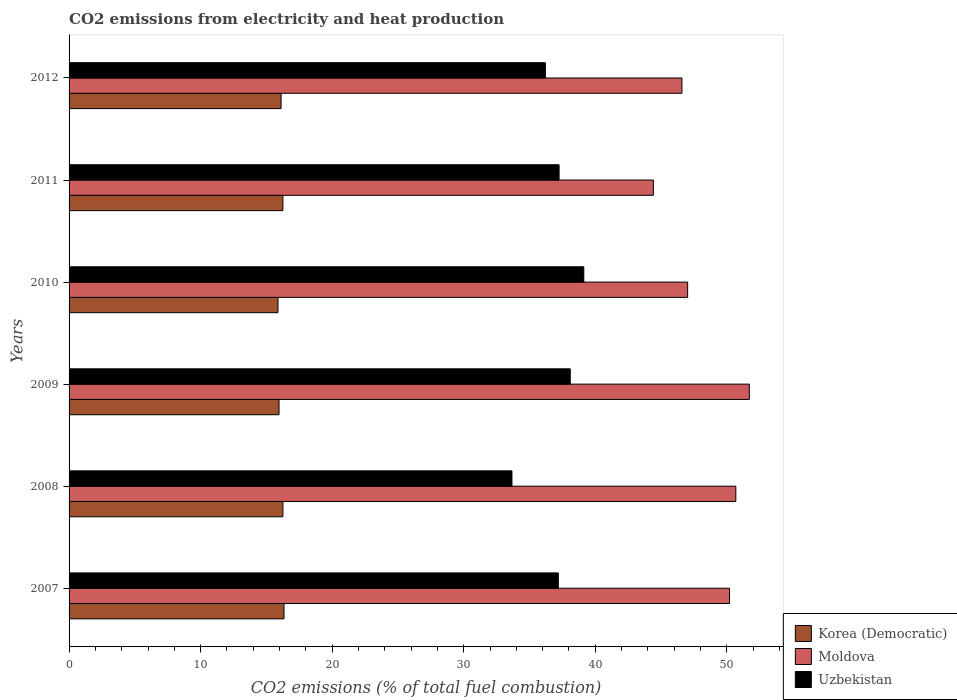How many different coloured bars are there?
Your answer should be very brief. 3. How many groups of bars are there?
Offer a terse response. 6. What is the label of the 4th group of bars from the top?
Give a very brief answer. 2009. What is the amount of CO2 emitted in Uzbekistan in 2007?
Ensure brevity in your answer.  37.19. Across all years, what is the maximum amount of CO2 emitted in Moldova?
Your response must be concise. 51.71. Across all years, what is the minimum amount of CO2 emitted in Korea (Democratic)?
Give a very brief answer. 15.88. In which year was the amount of CO2 emitted in Moldova maximum?
Offer a terse response. 2009. What is the total amount of CO2 emitted in Moldova in the graph?
Offer a terse response. 290.62. What is the difference between the amount of CO2 emitted in Korea (Democratic) in 2009 and that in 2011?
Your answer should be very brief. -0.29. What is the difference between the amount of CO2 emitted in Korea (Democratic) in 2011 and the amount of CO2 emitted in Uzbekistan in 2007?
Ensure brevity in your answer.  -20.94. What is the average amount of CO2 emitted in Moldova per year?
Your answer should be very brief. 48.44. In the year 2011, what is the difference between the amount of CO2 emitted in Uzbekistan and amount of CO2 emitted in Moldova?
Offer a very short reply. -7.17. In how many years, is the amount of CO2 emitted in Korea (Democratic) greater than 16 %?
Ensure brevity in your answer.  4. What is the ratio of the amount of CO2 emitted in Korea (Democratic) in 2010 to that in 2012?
Offer a terse response. 0.99. Is the difference between the amount of CO2 emitted in Uzbekistan in 2007 and 2011 greater than the difference between the amount of CO2 emitted in Moldova in 2007 and 2011?
Keep it short and to the point. No. What is the difference between the highest and the second highest amount of CO2 emitted in Moldova?
Your answer should be very brief. 1.03. What is the difference between the highest and the lowest amount of CO2 emitted in Uzbekistan?
Keep it short and to the point. 5.46. In how many years, is the amount of CO2 emitted in Korea (Democratic) greater than the average amount of CO2 emitted in Korea (Democratic) taken over all years?
Give a very brief answer. 3. Is the sum of the amount of CO2 emitted in Uzbekistan in 2008 and 2009 greater than the maximum amount of CO2 emitted in Korea (Democratic) across all years?
Your response must be concise. Yes. What does the 1st bar from the top in 2010 represents?
Make the answer very short. Uzbekistan. What does the 2nd bar from the bottom in 2010 represents?
Offer a very short reply. Moldova. How many bars are there?
Your answer should be very brief. 18. Are all the bars in the graph horizontal?
Ensure brevity in your answer.  Yes. How many years are there in the graph?
Offer a terse response. 6. What is the difference between two consecutive major ticks on the X-axis?
Your answer should be compact. 10. Does the graph contain any zero values?
Provide a succinct answer. No. Where does the legend appear in the graph?
Ensure brevity in your answer.  Bottom right. How many legend labels are there?
Make the answer very short. 3. What is the title of the graph?
Make the answer very short. CO2 emissions from electricity and heat production. What is the label or title of the X-axis?
Offer a very short reply. CO2 emissions (% of total fuel combustion). What is the label or title of the Y-axis?
Make the answer very short. Years. What is the CO2 emissions (% of total fuel combustion) of Korea (Democratic) in 2007?
Keep it short and to the point. 16.34. What is the CO2 emissions (% of total fuel combustion) of Moldova in 2007?
Your response must be concise. 50.2. What is the CO2 emissions (% of total fuel combustion) in Uzbekistan in 2007?
Your response must be concise. 37.19. What is the CO2 emissions (% of total fuel combustion) of Korea (Democratic) in 2008?
Offer a very short reply. 16.26. What is the CO2 emissions (% of total fuel combustion) of Moldova in 2008?
Ensure brevity in your answer.  50.68. What is the CO2 emissions (% of total fuel combustion) in Uzbekistan in 2008?
Give a very brief answer. 33.67. What is the CO2 emissions (% of total fuel combustion) of Korea (Democratic) in 2009?
Offer a terse response. 15.96. What is the CO2 emissions (% of total fuel combustion) of Moldova in 2009?
Give a very brief answer. 51.71. What is the CO2 emissions (% of total fuel combustion) of Uzbekistan in 2009?
Make the answer very short. 38.1. What is the CO2 emissions (% of total fuel combustion) in Korea (Democratic) in 2010?
Your answer should be very brief. 15.88. What is the CO2 emissions (% of total fuel combustion) of Moldova in 2010?
Give a very brief answer. 47.02. What is the CO2 emissions (% of total fuel combustion) of Uzbekistan in 2010?
Keep it short and to the point. 39.13. What is the CO2 emissions (% of total fuel combustion) in Korea (Democratic) in 2011?
Offer a terse response. 16.25. What is the CO2 emissions (% of total fuel combustion) of Moldova in 2011?
Provide a succinct answer. 44.42. What is the CO2 emissions (% of total fuel combustion) of Uzbekistan in 2011?
Your answer should be compact. 37.25. What is the CO2 emissions (% of total fuel combustion) of Korea (Democratic) in 2012?
Give a very brief answer. 16.12. What is the CO2 emissions (% of total fuel combustion) of Moldova in 2012?
Provide a succinct answer. 46.59. What is the CO2 emissions (% of total fuel combustion) of Uzbekistan in 2012?
Ensure brevity in your answer.  36.21. Across all years, what is the maximum CO2 emissions (% of total fuel combustion) of Korea (Democratic)?
Provide a short and direct response. 16.34. Across all years, what is the maximum CO2 emissions (% of total fuel combustion) of Moldova?
Your answer should be very brief. 51.71. Across all years, what is the maximum CO2 emissions (% of total fuel combustion) in Uzbekistan?
Provide a succinct answer. 39.13. Across all years, what is the minimum CO2 emissions (% of total fuel combustion) of Korea (Democratic)?
Your answer should be very brief. 15.88. Across all years, what is the minimum CO2 emissions (% of total fuel combustion) in Moldova?
Give a very brief answer. 44.42. Across all years, what is the minimum CO2 emissions (% of total fuel combustion) in Uzbekistan?
Offer a terse response. 33.67. What is the total CO2 emissions (% of total fuel combustion) of Korea (Democratic) in the graph?
Provide a short and direct response. 96.81. What is the total CO2 emissions (% of total fuel combustion) in Moldova in the graph?
Your answer should be very brief. 290.62. What is the total CO2 emissions (% of total fuel combustion) in Uzbekistan in the graph?
Offer a very short reply. 221.54. What is the difference between the CO2 emissions (% of total fuel combustion) of Korea (Democratic) in 2007 and that in 2008?
Provide a short and direct response. 0.08. What is the difference between the CO2 emissions (% of total fuel combustion) of Moldova in 2007 and that in 2008?
Your answer should be compact. -0.48. What is the difference between the CO2 emissions (% of total fuel combustion) in Uzbekistan in 2007 and that in 2008?
Provide a succinct answer. 3.53. What is the difference between the CO2 emissions (% of total fuel combustion) in Korea (Democratic) in 2007 and that in 2009?
Provide a succinct answer. 0.38. What is the difference between the CO2 emissions (% of total fuel combustion) in Moldova in 2007 and that in 2009?
Your answer should be very brief. -1.51. What is the difference between the CO2 emissions (% of total fuel combustion) of Uzbekistan in 2007 and that in 2009?
Provide a succinct answer. -0.91. What is the difference between the CO2 emissions (% of total fuel combustion) of Korea (Democratic) in 2007 and that in 2010?
Ensure brevity in your answer.  0.46. What is the difference between the CO2 emissions (% of total fuel combustion) in Moldova in 2007 and that in 2010?
Offer a very short reply. 3.18. What is the difference between the CO2 emissions (% of total fuel combustion) of Uzbekistan in 2007 and that in 2010?
Give a very brief answer. -1.94. What is the difference between the CO2 emissions (% of total fuel combustion) in Korea (Democratic) in 2007 and that in 2011?
Provide a short and direct response. 0.09. What is the difference between the CO2 emissions (% of total fuel combustion) in Moldova in 2007 and that in 2011?
Give a very brief answer. 5.79. What is the difference between the CO2 emissions (% of total fuel combustion) of Uzbekistan in 2007 and that in 2011?
Provide a succinct answer. -0.06. What is the difference between the CO2 emissions (% of total fuel combustion) in Korea (Democratic) in 2007 and that in 2012?
Make the answer very short. 0.22. What is the difference between the CO2 emissions (% of total fuel combustion) of Moldova in 2007 and that in 2012?
Your response must be concise. 3.62. What is the difference between the CO2 emissions (% of total fuel combustion) of Uzbekistan in 2007 and that in 2012?
Give a very brief answer. 0.98. What is the difference between the CO2 emissions (% of total fuel combustion) of Korea (Democratic) in 2008 and that in 2009?
Your answer should be very brief. 0.29. What is the difference between the CO2 emissions (% of total fuel combustion) in Moldova in 2008 and that in 2009?
Make the answer very short. -1.03. What is the difference between the CO2 emissions (% of total fuel combustion) in Uzbekistan in 2008 and that in 2009?
Give a very brief answer. -4.43. What is the difference between the CO2 emissions (% of total fuel combustion) of Korea (Democratic) in 2008 and that in 2010?
Ensure brevity in your answer.  0.38. What is the difference between the CO2 emissions (% of total fuel combustion) of Moldova in 2008 and that in 2010?
Offer a very short reply. 3.66. What is the difference between the CO2 emissions (% of total fuel combustion) in Uzbekistan in 2008 and that in 2010?
Provide a succinct answer. -5.46. What is the difference between the CO2 emissions (% of total fuel combustion) of Korea (Democratic) in 2008 and that in 2011?
Provide a succinct answer. 0. What is the difference between the CO2 emissions (% of total fuel combustion) of Moldova in 2008 and that in 2011?
Your answer should be compact. 6.27. What is the difference between the CO2 emissions (% of total fuel combustion) in Uzbekistan in 2008 and that in 2011?
Your answer should be compact. -3.58. What is the difference between the CO2 emissions (% of total fuel combustion) of Korea (Democratic) in 2008 and that in 2012?
Your answer should be compact. 0.14. What is the difference between the CO2 emissions (% of total fuel combustion) in Moldova in 2008 and that in 2012?
Provide a short and direct response. 4.1. What is the difference between the CO2 emissions (% of total fuel combustion) in Uzbekistan in 2008 and that in 2012?
Your response must be concise. -2.54. What is the difference between the CO2 emissions (% of total fuel combustion) in Korea (Democratic) in 2009 and that in 2010?
Give a very brief answer. 0.08. What is the difference between the CO2 emissions (% of total fuel combustion) of Moldova in 2009 and that in 2010?
Make the answer very short. 4.69. What is the difference between the CO2 emissions (% of total fuel combustion) in Uzbekistan in 2009 and that in 2010?
Your response must be concise. -1.03. What is the difference between the CO2 emissions (% of total fuel combustion) in Korea (Democratic) in 2009 and that in 2011?
Provide a short and direct response. -0.29. What is the difference between the CO2 emissions (% of total fuel combustion) in Moldova in 2009 and that in 2011?
Your response must be concise. 7.29. What is the difference between the CO2 emissions (% of total fuel combustion) in Uzbekistan in 2009 and that in 2011?
Provide a short and direct response. 0.85. What is the difference between the CO2 emissions (% of total fuel combustion) of Korea (Democratic) in 2009 and that in 2012?
Your response must be concise. -0.16. What is the difference between the CO2 emissions (% of total fuel combustion) of Moldova in 2009 and that in 2012?
Provide a succinct answer. 5.12. What is the difference between the CO2 emissions (% of total fuel combustion) in Uzbekistan in 2009 and that in 2012?
Your answer should be very brief. 1.89. What is the difference between the CO2 emissions (% of total fuel combustion) of Korea (Democratic) in 2010 and that in 2011?
Provide a succinct answer. -0.37. What is the difference between the CO2 emissions (% of total fuel combustion) in Moldova in 2010 and that in 2011?
Ensure brevity in your answer.  2.61. What is the difference between the CO2 emissions (% of total fuel combustion) of Uzbekistan in 2010 and that in 2011?
Make the answer very short. 1.88. What is the difference between the CO2 emissions (% of total fuel combustion) of Korea (Democratic) in 2010 and that in 2012?
Your response must be concise. -0.24. What is the difference between the CO2 emissions (% of total fuel combustion) of Moldova in 2010 and that in 2012?
Provide a short and direct response. 0.43. What is the difference between the CO2 emissions (% of total fuel combustion) of Uzbekistan in 2010 and that in 2012?
Your answer should be very brief. 2.92. What is the difference between the CO2 emissions (% of total fuel combustion) in Korea (Democratic) in 2011 and that in 2012?
Provide a succinct answer. 0.14. What is the difference between the CO2 emissions (% of total fuel combustion) of Moldova in 2011 and that in 2012?
Provide a succinct answer. -2.17. What is the difference between the CO2 emissions (% of total fuel combustion) in Uzbekistan in 2011 and that in 2012?
Provide a succinct answer. 1.04. What is the difference between the CO2 emissions (% of total fuel combustion) of Korea (Democratic) in 2007 and the CO2 emissions (% of total fuel combustion) of Moldova in 2008?
Ensure brevity in your answer.  -34.34. What is the difference between the CO2 emissions (% of total fuel combustion) in Korea (Democratic) in 2007 and the CO2 emissions (% of total fuel combustion) in Uzbekistan in 2008?
Keep it short and to the point. -17.33. What is the difference between the CO2 emissions (% of total fuel combustion) of Moldova in 2007 and the CO2 emissions (% of total fuel combustion) of Uzbekistan in 2008?
Ensure brevity in your answer.  16.54. What is the difference between the CO2 emissions (% of total fuel combustion) in Korea (Democratic) in 2007 and the CO2 emissions (% of total fuel combustion) in Moldova in 2009?
Your answer should be compact. -35.37. What is the difference between the CO2 emissions (% of total fuel combustion) in Korea (Democratic) in 2007 and the CO2 emissions (% of total fuel combustion) in Uzbekistan in 2009?
Make the answer very short. -21.76. What is the difference between the CO2 emissions (% of total fuel combustion) in Moldova in 2007 and the CO2 emissions (% of total fuel combustion) in Uzbekistan in 2009?
Your answer should be compact. 12.11. What is the difference between the CO2 emissions (% of total fuel combustion) in Korea (Democratic) in 2007 and the CO2 emissions (% of total fuel combustion) in Moldova in 2010?
Keep it short and to the point. -30.68. What is the difference between the CO2 emissions (% of total fuel combustion) in Korea (Democratic) in 2007 and the CO2 emissions (% of total fuel combustion) in Uzbekistan in 2010?
Keep it short and to the point. -22.79. What is the difference between the CO2 emissions (% of total fuel combustion) in Moldova in 2007 and the CO2 emissions (% of total fuel combustion) in Uzbekistan in 2010?
Keep it short and to the point. 11.08. What is the difference between the CO2 emissions (% of total fuel combustion) in Korea (Democratic) in 2007 and the CO2 emissions (% of total fuel combustion) in Moldova in 2011?
Offer a terse response. -28.08. What is the difference between the CO2 emissions (% of total fuel combustion) in Korea (Democratic) in 2007 and the CO2 emissions (% of total fuel combustion) in Uzbekistan in 2011?
Offer a terse response. -20.91. What is the difference between the CO2 emissions (% of total fuel combustion) in Moldova in 2007 and the CO2 emissions (% of total fuel combustion) in Uzbekistan in 2011?
Give a very brief answer. 12.95. What is the difference between the CO2 emissions (% of total fuel combustion) of Korea (Democratic) in 2007 and the CO2 emissions (% of total fuel combustion) of Moldova in 2012?
Give a very brief answer. -30.25. What is the difference between the CO2 emissions (% of total fuel combustion) of Korea (Democratic) in 2007 and the CO2 emissions (% of total fuel combustion) of Uzbekistan in 2012?
Give a very brief answer. -19.87. What is the difference between the CO2 emissions (% of total fuel combustion) of Moldova in 2007 and the CO2 emissions (% of total fuel combustion) of Uzbekistan in 2012?
Your answer should be very brief. 14. What is the difference between the CO2 emissions (% of total fuel combustion) in Korea (Democratic) in 2008 and the CO2 emissions (% of total fuel combustion) in Moldova in 2009?
Offer a terse response. -35.45. What is the difference between the CO2 emissions (% of total fuel combustion) of Korea (Democratic) in 2008 and the CO2 emissions (% of total fuel combustion) of Uzbekistan in 2009?
Ensure brevity in your answer.  -21.84. What is the difference between the CO2 emissions (% of total fuel combustion) in Moldova in 2008 and the CO2 emissions (% of total fuel combustion) in Uzbekistan in 2009?
Provide a short and direct response. 12.58. What is the difference between the CO2 emissions (% of total fuel combustion) of Korea (Democratic) in 2008 and the CO2 emissions (% of total fuel combustion) of Moldova in 2010?
Your answer should be compact. -30.77. What is the difference between the CO2 emissions (% of total fuel combustion) of Korea (Democratic) in 2008 and the CO2 emissions (% of total fuel combustion) of Uzbekistan in 2010?
Keep it short and to the point. -22.87. What is the difference between the CO2 emissions (% of total fuel combustion) in Moldova in 2008 and the CO2 emissions (% of total fuel combustion) in Uzbekistan in 2010?
Ensure brevity in your answer.  11.56. What is the difference between the CO2 emissions (% of total fuel combustion) in Korea (Democratic) in 2008 and the CO2 emissions (% of total fuel combustion) in Moldova in 2011?
Offer a very short reply. -28.16. What is the difference between the CO2 emissions (% of total fuel combustion) of Korea (Democratic) in 2008 and the CO2 emissions (% of total fuel combustion) of Uzbekistan in 2011?
Your answer should be very brief. -20.99. What is the difference between the CO2 emissions (% of total fuel combustion) in Moldova in 2008 and the CO2 emissions (% of total fuel combustion) in Uzbekistan in 2011?
Your answer should be compact. 13.43. What is the difference between the CO2 emissions (% of total fuel combustion) in Korea (Democratic) in 2008 and the CO2 emissions (% of total fuel combustion) in Moldova in 2012?
Make the answer very short. -30.33. What is the difference between the CO2 emissions (% of total fuel combustion) of Korea (Democratic) in 2008 and the CO2 emissions (% of total fuel combustion) of Uzbekistan in 2012?
Keep it short and to the point. -19.95. What is the difference between the CO2 emissions (% of total fuel combustion) of Moldova in 2008 and the CO2 emissions (% of total fuel combustion) of Uzbekistan in 2012?
Keep it short and to the point. 14.48. What is the difference between the CO2 emissions (% of total fuel combustion) of Korea (Democratic) in 2009 and the CO2 emissions (% of total fuel combustion) of Moldova in 2010?
Your answer should be very brief. -31.06. What is the difference between the CO2 emissions (% of total fuel combustion) of Korea (Democratic) in 2009 and the CO2 emissions (% of total fuel combustion) of Uzbekistan in 2010?
Offer a terse response. -23.17. What is the difference between the CO2 emissions (% of total fuel combustion) in Moldova in 2009 and the CO2 emissions (% of total fuel combustion) in Uzbekistan in 2010?
Provide a short and direct response. 12.58. What is the difference between the CO2 emissions (% of total fuel combustion) in Korea (Democratic) in 2009 and the CO2 emissions (% of total fuel combustion) in Moldova in 2011?
Your answer should be compact. -28.46. What is the difference between the CO2 emissions (% of total fuel combustion) of Korea (Democratic) in 2009 and the CO2 emissions (% of total fuel combustion) of Uzbekistan in 2011?
Ensure brevity in your answer.  -21.29. What is the difference between the CO2 emissions (% of total fuel combustion) in Moldova in 2009 and the CO2 emissions (% of total fuel combustion) in Uzbekistan in 2011?
Keep it short and to the point. 14.46. What is the difference between the CO2 emissions (% of total fuel combustion) of Korea (Democratic) in 2009 and the CO2 emissions (% of total fuel combustion) of Moldova in 2012?
Your response must be concise. -30.63. What is the difference between the CO2 emissions (% of total fuel combustion) of Korea (Democratic) in 2009 and the CO2 emissions (% of total fuel combustion) of Uzbekistan in 2012?
Make the answer very short. -20.25. What is the difference between the CO2 emissions (% of total fuel combustion) of Moldova in 2009 and the CO2 emissions (% of total fuel combustion) of Uzbekistan in 2012?
Provide a succinct answer. 15.5. What is the difference between the CO2 emissions (% of total fuel combustion) of Korea (Democratic) in 2010 and the CO2 emissions (% of total fuel combustion) of Moldova in 2011?
Give a very brief answer. -28.54. What is the difference between the CO2 emissions (% of total fuel combustion) in Korea (Democratic) in 2010 and the CO2 emissions (% of total fuel combustion) in Uzbekistan in 2011?
Offer a very short reply. -21.37. What is the difference between the CO2 emissions (% of total fuel combustion) of Moldova in 2010 and the CO2 emissions (% of total fuel combustion) of Uzbekistan in 2011?
Offer a very short reply. 9.77. What is the difference between the CO2 emissions (% of total fuel combustion) of Korea (Democratic) in 2010 and the CO2 emissions (% of total fuel combustion) of Moldova in 2012?
Provide a succinct answer. -30.71. What is the difference between the CO2 emissions (% of total fuel combustion) of Korea (Democratic) in 2010 and the CO2 emissions (% of total fuel combustion) of Uzbekistan in 2012?
Give a very brief answer. -20.33. What is the difference between the CO2 emissions (% of total fuel combustion) of Moldova in 2010 and the CO2 emissions (% of total fuel combustion) of Uzbekistan in 2012?
Your answer should be compact. 10.81. What is the difference between the CO2 emissions (% of total fuel combustion) of Korea (Democratic) in 2011 and the CO2 emissions (% of total fuel combustion) of Moldova in 2012?
Offer a very short reply. -30.33. What is the difference between the CO2 emissions (% of total fuel combustion) in Korea (Democratic) in 2011 and the CO2 emissions (% of total fuel combustion) in Uzbekistan in 2012?
Your answer should be very brief. -19.95. What is the difference between the CO2 emissions (% of total fuel combustion) of Moldova in 2011 and the CO2 emissions (% of total fuel combustion) of Uzbekistan in 2012?
Make the answer very short. 8.21. What is the average CO2 emissions (% of total fuel combustion) of Korea (Democratic) per year?
Ensure brevity in your answer.  16.13. What is the average CO2 emissions (% of total fuel combustion) of Moldova per year?
Offer a terse response. 48.44. What is the average CO2 emissions (% of total fuel combustion) of Uzbekistan per year?
Make the answer very short. 36.92. In the year 2007, what is the difference between the CO2 emissions (% of total fuel combustion) in Korea (Democratic) and CO2 emissions (% of total fuel combustion) in Moldova?
Provide a succinct answer. -33.87. In the year 2007, what is the difference between the CO2 emissions (% of total fuel combustion) in Korea (Democratic) and CO2 emissions (% of total fuel combustion) in Uzbekistan?
Offer a very short reply. -20.85. In the year 2007, what is the difference between the CO2 emissions (% of total fuel combustion) in Moldova and CO2 emissions (% of total fuel combustion) in Uzbekistan?
Provide a short and direct response. 13.01. In the year 2008, what is the difference between the CO2 emissions (% of total fuel combustion) of Korea (Democratic) and CO2 emissions (% of total fuel combustion) of Moldova?
Make the answer very short. -34.43. In the year 2008, what is the difference between the CO2 emissions (% of total fuel combustion) in Korea (Democratic) and CO2 emissions (% of total fuel combustion) in Uzbekistan?
Ensure brevity in your answer.  -17.41. In the year 2008, what is the difference between the CO2 emissions (% of total fuel combustion) in Moldova and CO2 emissions (% of total fuel combustion) in Uzbekistan?
Give a very brief answer. 17.02. In the year 2009, what is the difference between the CO2 emissions (% of total fuel combustion) of Korea (Democratic) and CO2 emissions (% of total fuel combustion) of Moldova?
Your answer should be compact. -35.75. In the year 2009, what is the difference between the CO2 emissions (% of total fuel combustion) of Korea (Democratic) and CO2 emissions (% of total fuel combustion) of Uzbekistan?
Offer a very short reply. -22.14. In the year 2009, what is the difference between the CO2 emissions (% of total fuel combustion) of Moldova and CO2 emissions (% of total fuel combustion) of Uzbekistan?
Your answer should be very brief. 13.61. In the year 2010, what is the difference between the CO2 emissions (% of total fuel combustion) of Korea (Democratic) and CO2 emissions (% of total fuel combustion) of Moldova?
Keep it short and to the point. -31.14. In the year 2010, what is the difference between the CO2 emissions (% of total fuel combustion) of Korea (Democratic) and CO2 emissions (% of total fuel combustion) of Uzbekistan?
Ensure brevity in your answer.  -23.25. In the year 2010, what is the difference between the CO2 emissions (% of total fuel combustion) in Moldova and CO2 emissions (% of total fuel combustion) in Uzbekistan?
Provide a succinct answer. 7.89. In the year 2011, what is the difference between the CO2 emissions (% of total fuel combustion) of Korea (Democratic) and CO2 emissions (% of total fuel combustion) of Moldova?
Make the answer very short. -28.16. In the year 2011, what is the difference between the CO2 emissions (% of total fuel combustion) of Korea (Democratic) and CO2 emissions (% of total fuel combustion) of Uzbekistan?
Your answer should be compact. -21. In the year 2011, what is the difference between the CO2 emissions (% of total fuel combustion) of Moldova and CO2 emissions (% of total fuel combustion) of Uzbekistan?
Your answer should be very brief. 7.17. In the year 2012, what is the difference between the CO2 emissions (% of total fuel combustion) in Korea (Democratic) and CO2 emissions (% of total fuel combustion) in Moldova?
Your answer should be very brief. -30.47. In the year 2012, what is the difference between the CO2 emissions (% of total fuel combustion) of Korea (Democratic) and CO2 emissions (% of total fuel combustion) of Uzbekistan?
Your answer should be very brief. -20.09. In the year 2012, what is the difference between the CO2 emissions (% of total fuel combustion) in Moldova and CO2 emissions (% of total fuel combustion) in Uzbekistan?
Make the answer very short. 10.38. What is the ratio of the CO2 emissions (% of total fuel combustion) in Uzbekistan in 2007 to that in 2008?
Your answer should be very brief. 1.1. What is the ratio of the CO2 emissions (% of total fuel combustion) in Korea (Democratic) in 2007 to that in 2009?
Make the answer very short. 1.02. What is the ratio of the CO2 emissions (% of total fuel combustion) in Moldova in 2007 to that in 2009?
Offer a very short reply. 0.97. What is the ratio of the CO2 emissions (% of total fuel combustion) in Uzbekistan in 2007 to that in 2009?
Provide a succinct answer. 0.98. What is the ratio of the CO2 emissions (% of total fuel combustion) in Korea (Democratic) in 2007 to that in 2010?
Provide a succinct answer. 1.03. What is the ratio of the CO2 emissions (% of total fuel combustion) of Moldova in 2007 to that in 2010?
Provide a succinct answer. 1.07. What is the ratio of the CO2 emissions (% of total fuel combustion) of Uzbekistan in 2007 to that in 2010?
Provide a short and direct response. 0.95. What is the ratio of the CO2 emissions (% of total fuel combustion) of Korea (Democratic) in 2007 to that in 2011?
Provide a short and direct response. 1.01. What is the ratio of the CO2 emissions (% of total fuel combustion) in Moldova in 2007 to that in 2011?
Your answer should be compact. 1.13. What is the ratio of the CO2 emissions (% of total fuel combustion) of Korea (Democratic) in 2007 to that in 2012?
Offer a terse response. 1.01. What is the ratio of the CO2 emissions (% of total fuel combustion) in Moldova in 2007 to that in 2012?
Offer a terse response. 1.08. What is the ratio of the CO2 emissions (% of total fuel combustion) in Uzbekistan in 2007 to that in 2012?
Offer a terse response. 1.03. What is the ratio of the CO2 emissions (% of total fuel combustion) of Korea (Democratic) in 2008 to that in 2009?
Give a very brief answer. 1.02. What is the ratio of the CO2 emissions (% of total fuel combustion) of Moldova in 2008 to that in 2009?
Offer a terse response. 0.98. What is the ratio of the CO2 emissions (% of total fuel combustion) in Uzbekistan in 2008 to that in 2009?
Offer a very short reply. 0.88. What is the ratio of the CO2 emissions (% of total fuel combustion) in Korea (Democratic) in 2008 to that in 2010?
Offer a terse response. 1.02. What is the ratio of the CO2 emissions (% of total fuel combustion) of Moldova in 2008 to that in 2010?
Make the answer very short. 1.08. What is the ratio of the CO2 emissions (% of total fuel combustion) of Uzbekistan in 2008 to that in 2010?
Provide a succinct answer. 0.86. What is the ratio of the CO2 emissions (% of total fuel combustion) in Moldova in 2008 to that in 2011?
Your answer should be very brief. 1.14. What is the ratio of the CO2 emissions (% of total fuel combustion) of Uzbekistan in 2008 to that in 2011?
Give a very brief answer. 0.9. What is the ratio of the CO2 emissions (% of total fuel combustion) in Korea (Democratic) in 2008 to that in 2012?
Provide a succinct answer. 1.01. What is the ratio of the CO2 emissions (% of total fuel combustion) of Moldova in 2008 to that in 2012?
Ensure brevity in your answer.  1.09. What is the ratio of the CO2 emissions (% of total fuel combustion) in Uzbekistan in 2008 to that in 2012?
Offer a very short reply. 0.93. What is the ratio of the CO2 emissions (% of total fuel combustion) in Moldova in 2009 to that in 2010?
Keep it short and to the point. 1.1. What is the ratio of the CO2 emissions (% of total fuel combustion) in Uzbekistan in 2009 to that in 2010?
Keep it short and to the point. 0.97. What is the ratio of the CO2 emissions (% of total fuel combustion) in Moldova in 2009 to that in 2011?
Provide a succinct answer. 1.16. What is the ratio of the CO2 emissions (% of total fuel combustion) in Uzbekistan in 2009 to that in 2011?
Give a very brief answer. 1.02. What is the ratio of the CO2 emissions (% of total fuel combustion) in Korea (Democratic) in 2009 to that in 2012?
Ensure brevity in your answer.  0.99. What is the ratio of the CO2 emissions (% of total fuel combustion) of Moldova in 2009 to that in 2012?
Make the answer very short. 1.11. What is the ratio of the CO2 emissions (% of total fuel combustion) in Uzbekistan in 2009 to that in 2012?
Provide a succinct answer. 1.05. What is the ratio of the CO2 emissions (% of total fuel combustion) in Korea (Democratic) in 2010 to that in 2011?
Your response must be concise. 0.98. What is the ratio of the CO2 emissions (% of total fuel combustion) of Moldova in 2010 to that in 2011?
Your answer should be very brief. 1.06. What is the ratio of the CO2 emissions (% of total fuel combustion) in Uzbekistan in 2010 to that in 2011?
Give a very brief answer. 1.05. What is the ratio of the CO2 emissions (% of total fuel combustion) of Korea (Democratic) in 2010 to that in 2012?
Your answer should be compact. 0.99. What is the ratio of the CO2 emissions (% of total fuel combustion) in Moldova in 2010 to that in 2012?
Provide a succinct answer. 1.01. What is the ratio of the CO2 emissions (% of total fuel combustion) of Uzbekistan in 2010 to that in 2012?
Offer a terse response. 1.08. What is the ratio of the CO2 emissions (% of total fuel combustion) of Korea (Democratic) in 2011 to that in 2012?
Provide a short and direct response. 1.01. What is the ratio of the CO2 emissions (% of total fuel combustion) of Moldova in 2011 to that in 2012?
Make the answer very short. 0.95. What is the ratio of the CO2 emissions (% of total fuel combustion) of Uzbekistan in 2011 to that in 2012?
Keep it short and to the point. 1.03. What is the difference between the highest and the second highest CO2 emissions (% of total fuel combustion) in Korea (Democratic)?
Make the answer very short. 0.08. What is the difference between the highest and the second highest CO2 emissions (% of total fuel combustion) of Moldova?
Your answer should be very brief. 1.03. What is the difference between the highest and the second highest CO2 emissions (% of total fuel combustion) in Uzbekistan?
Give a very brief answer. 1.03. What is the difference between the highest and the lowest CO2 emissions (% of total fuel combustion) of Korea (Democratic)?
Offer a terse response. 0.46. What is the difference between the highest and the lowest CO2 emissions (% of total fuel combustion) in Moldova?
Your answer should be very brief. 7.29. What is the difference between the highest and the lowest CO2 emissions (% of total fuel combustion) in Uzbekistan?
Keep it short and to the point. 5.46. 